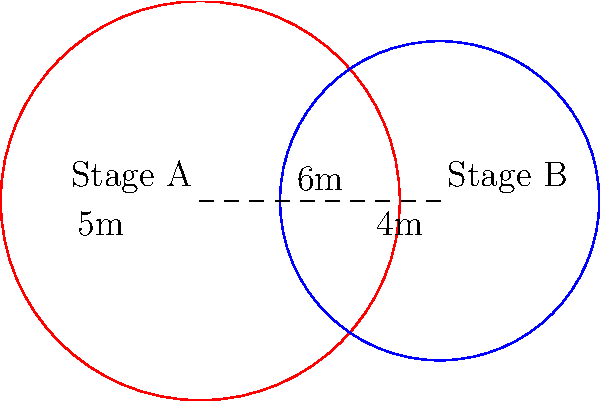At a Christmas concert, two circular stage platforms are set up for different performances. Stage A has a radius of 5 meters, and Stage B has a radius of 4 meters. The centers of the stages are 6 meters apart. Calculate the area of the overlapping region where both stages intersect, rounding your answer to the nearest square meter. How much space is available for performers to move between both stages? Let's solve this step-by-step:

1) First, we need to determine if the circles intersect. The distance between centers (6m) is less than the sum of radii (5m + 4m = 9m), so they do intersect.

2) To find the area of overlap, we'll use the formula for the area of intersection of two circles:

   $$A = r_1^2 \arccos(\frac{d^2 + r_1^2 - r_2^2}{2dr_1}) + r_2^2 \arccos(\frac{d^2 + r_2^2 - r_1^2}{2dr_2}) - \frac{1}{2}\sqrt{(-d+r_1+r_2)(d+r_1-r_2)(d-r_1+r_2)(d+r_1+r_2)}$$

   Where $r_1$ and $r_2$ are the radii of the circles, and $d$ is the distance between their centers.

3) Let's substitute our values:
   $r_1 = 5$, $r_2 = 4$, $d = 6$

4) Calculating each part:
   $$5^2 \arccos(\frac{6^2 + 5^2 - 4^2}{2 \cdot 6 \cdot 5}) \approx 13.7444$$
   $$4^2 \arccos(\frac{6^2 + 4^2 - 5^2}{2 \cdot 6 \cdot 4}) \approx 6.1960$$
   $$\frac{1}{2}\sqrt{(-6+5+4)(6+5-4)(6-5+4)(6+5+4)} \approx 11.3137$$

5) Adding the first two terms and subtracting the third:
   $$13.7444 + 6.1960 - 11.3137 \approx 8.6267$$

6) Rounding to the nearest square meter:
   $$8.6267 \approx 9 \text{ m}^2$$

Therefore, the overlapping area where performers can move between both stages is approximately 9 square meters.
Answer: 9 m² 